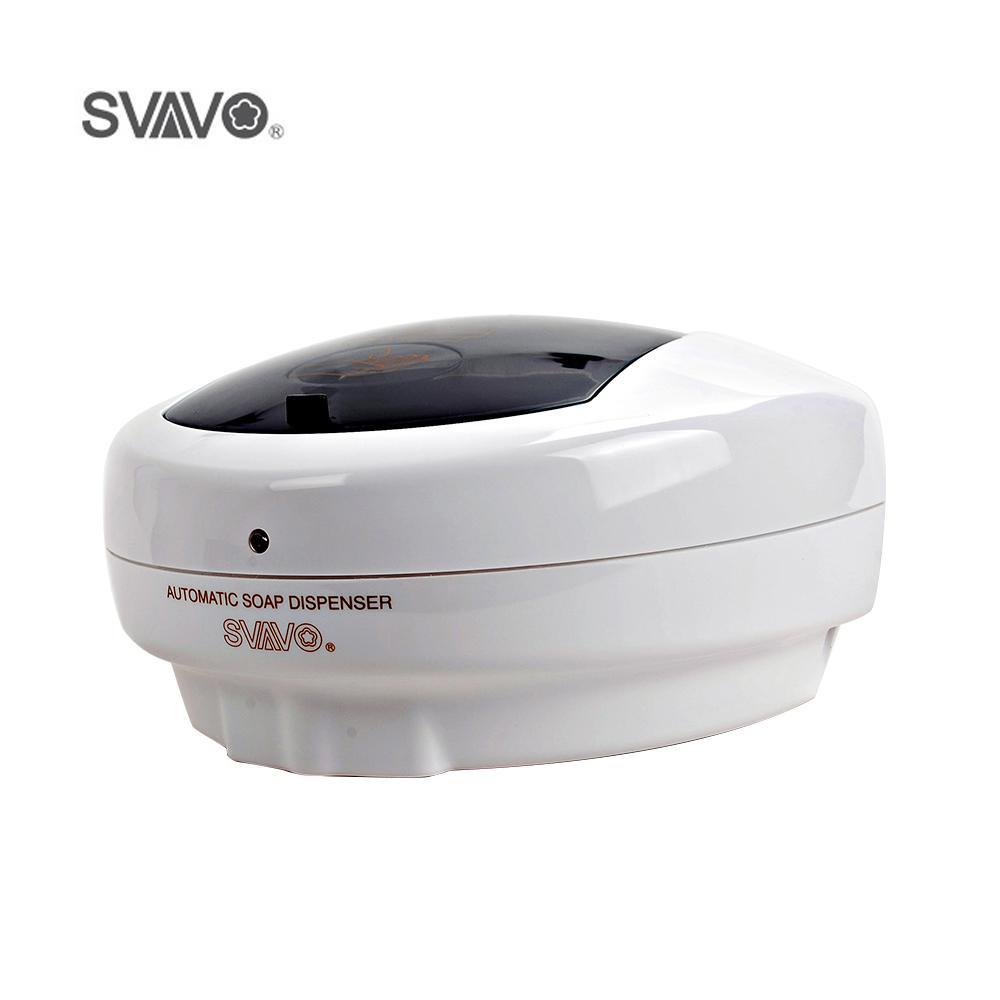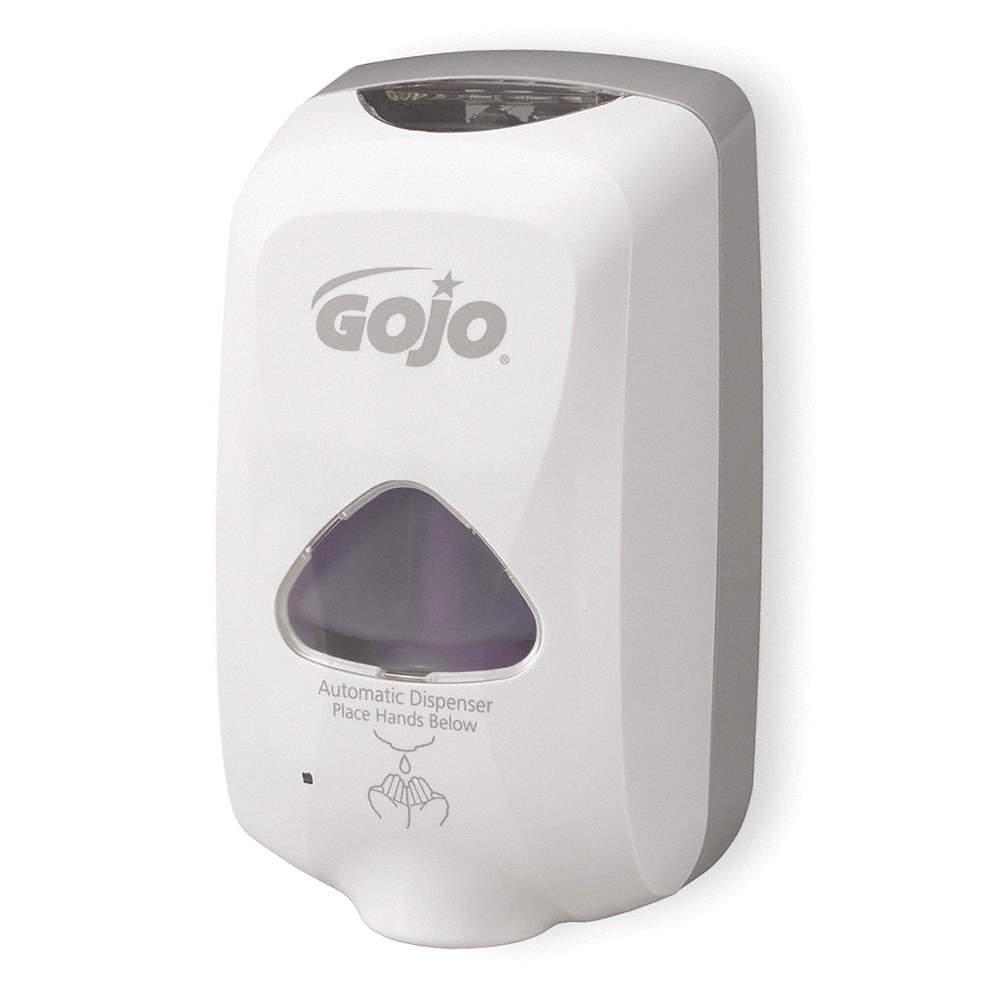The first image is the image on the left, the second image is the image on the right. Given the left and right images, does the statement "The left and right image contains the same number of wall hanging soap dispensers." hold true? Answer yes or no. Yes. The first image is the image on the left, the second image is the image on the right. Assess this claim about the two images: "One image features a white-fronted wall-mount dispenser that is taller than it is wide, and the other image features a dispenser with a white bottom and a shiny transparent convex top.". Correct or not? Answer yes or no. Yes. 